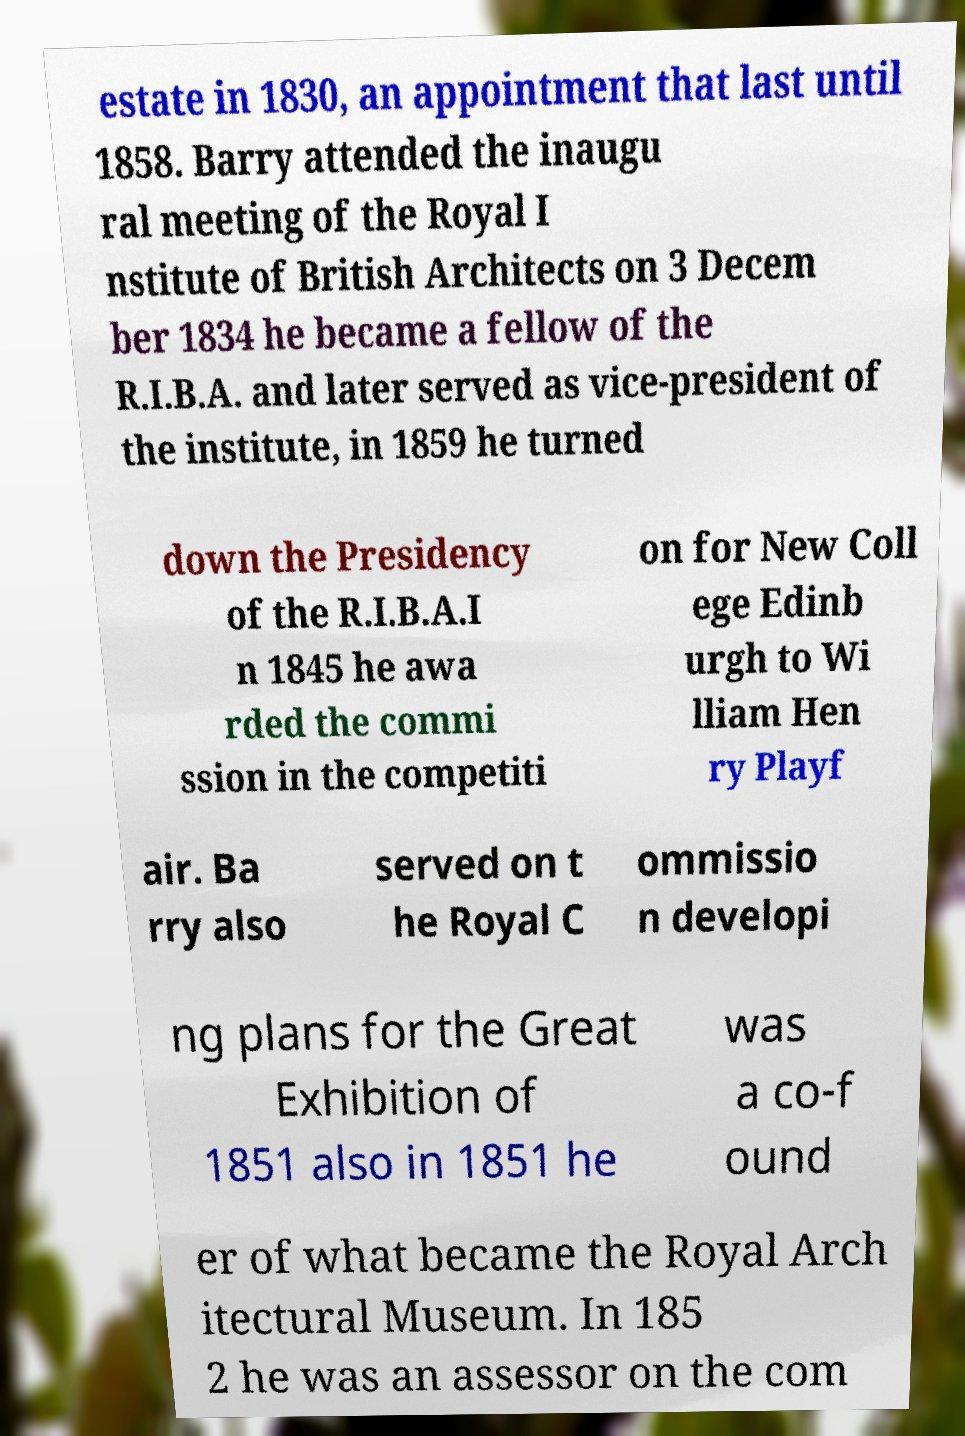Can you read and provide the text displayed in the image?This photo seems to have some interesting text. Can you extract and type it out for me? estate in 1830, an appointment that last until 1858. Barry attended the inaugu ral meeting of the Royal I nstitute of British Architects on 3 Decem ber 1834 he became a fellow of the R.I.B.A. and later served as vice-president of the institute, in 1859 he turned down the Presidency of the R.I.B.A.I n 1845 he awa rded the commi ssion in the competiti on for New Coll ege Edinb urgh to Wi lliam Hen ry Playf air. Ba rry also served on t he Royal C ommissio n developi ng plans for the Great Exhibition of 1851 also in 1851 he was a co-f ound er of what became the Royal Arch itectural Museum. In 185 2 he was an assessor on the com 